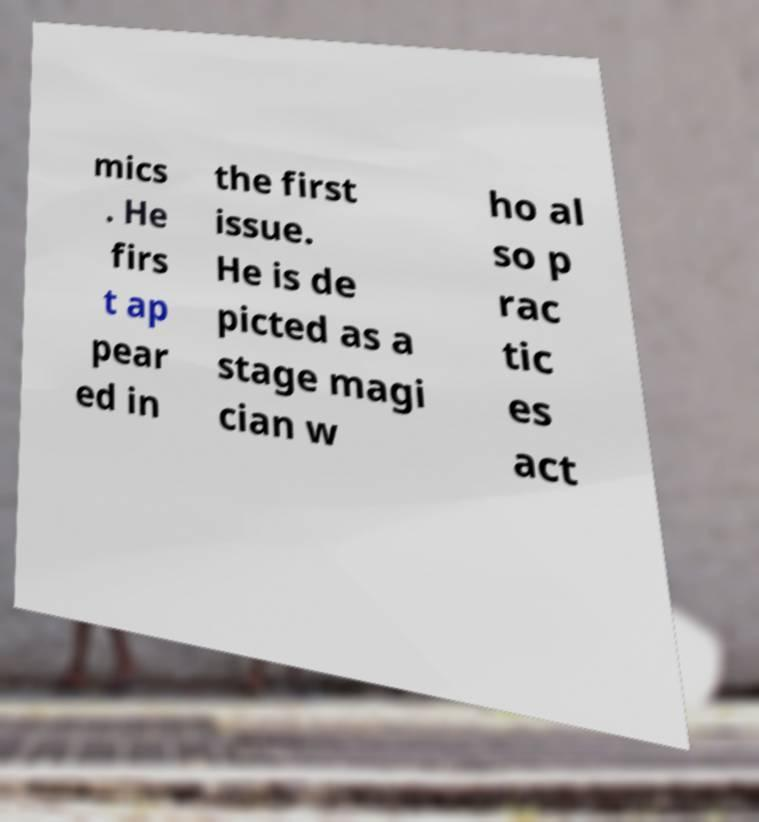I need the written content from this picture converted into text. Can you do that? mics . He firs t ap pear ed in the first issue. He is de picted as a stage magi cian w ho al so p rac tic es act 